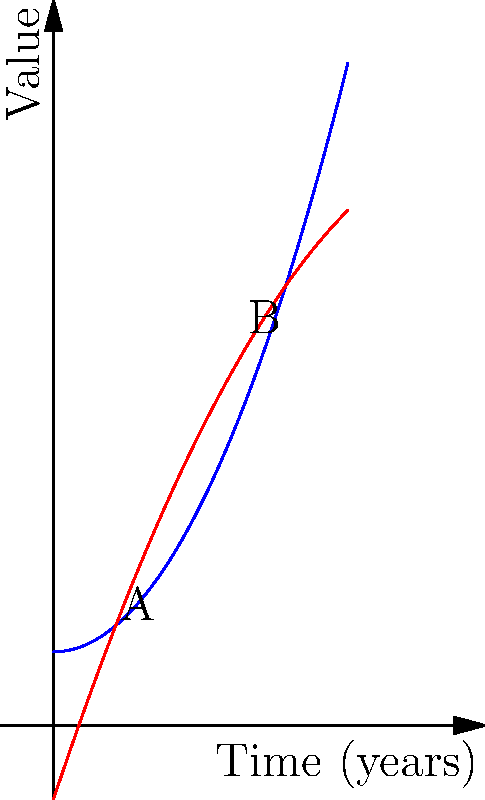The blue curve represents population growth, and the red curve represents economic output over time in a developing country. Both are influenced by demographic shifts. The curves intersect at points A and B. Calculate the area between these curves from point A to point B. To find the area between the curves, we need to:

1. Identify the functions:
   Blue curve (population growth): $f(x) = 0.5x^2 + 1$
   Red curve (economic output): $g(x) = -0.25x^2 + 3x - 1$

2. Find the intersection points A and B:
   Set $f(x) = g(x)$:
   $0.5x^2 + 1 = -0.25x^2 + 3x - 1$
   $0.75x^2 - 3x + 2 = 0$
   Solving this quadratic equation gives $x ≈ 0.77$ and $x ≈ 3.23$

3. Set up the integral to calculate the area:
   Area = $\int_{0.77}^{3.23} [g(x) - f(x)] dx$

4. Evaluate the integral:
   $\int_{0.77}^{3.23} [(-0.25x^2 + 3x - 1) - (0.5x^2 + 1)] dx$
   $= \int_{0.77}^{3.23} [-0.75x^2 + 3x - 2] dx$
   $= [-0.25x^3 + 1.5x^2 - 2x]_{0.77}^{3.23}$

5. Calculate the result:
   $= [-0.25(3.23)^3 + 1.5(3.23)^2 - 2(3.23)] - [-0.25(0.77)^3 + 1.5(0.77)^2 - 2(0.77)]$
   $≈ 3.62$

Therefore, the area between the curves from point A to point B is approximately 3.62 units².
Answer: 3.62 units² 